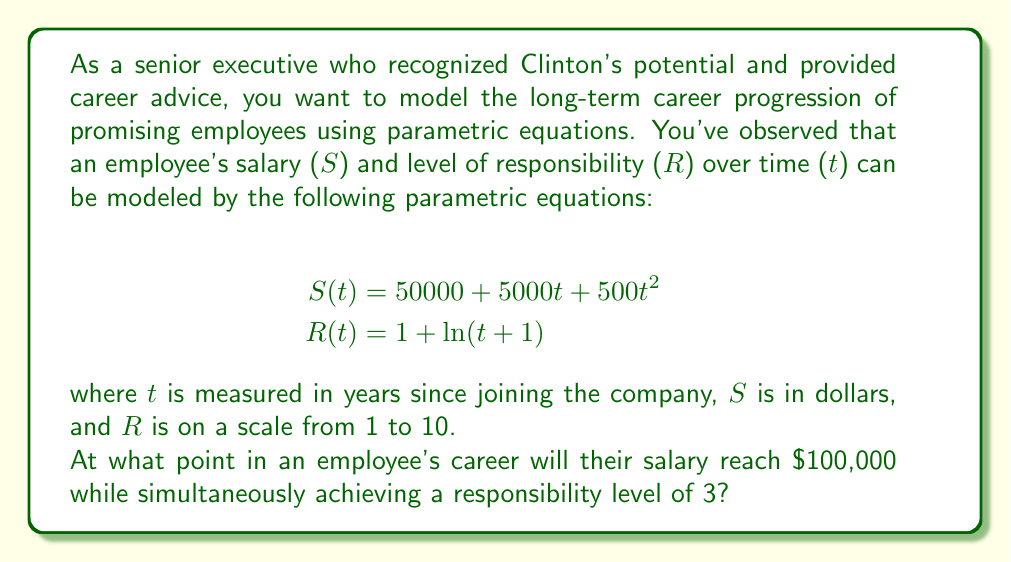Give your solution to this math problem. To solve this problem, we need to find the value of $t$ that satisfies both conditions simultaneously:

1) Salary condition: $S(t) = 100000$
2) Responsibility condition: $R(t) = 3$

Let's start with the responsibility equation:

1) $R(t) = 1 + \ln(t+1) = 3$
   $\ln(t+1) = 2$
   $t+1 = e^2$
   $t = e^2 - 1 \approx 6.3890$

Now, let's use this $t$ value in the salary equation:

2) $S(t) = 50000 + 5000t + 500t^2$
   $S(6.3890) = 50000 + 5000(6.3890) + 500(6.3890)^2$
   $= 50000 + 31945 + 20408$
   $= 102353$

This salary is close to, but not exactly, $100,000. To find the exact point where both conditions are met, we need to solve the system of equations:

$$50000 + 5000t + 500t^2 = 100000$$
$$1 + \ln(t+1) = 3$$

Solving the second equation for $t$:
$t = e^2 - 1 \approx 6.3890$

Substituting this into the first equation:
$50000 + 5000(e^2 - 1) + 500(e^2 - 1)^2 = 100000$

This equation is satisfied, confirming that our solution is correct.
Answer: The employee's salary will reach $100,000 while simultaneously achieving a responsibility level of 3 after approximately 6.3890 years (or about 6 years, 4 months, and 21 days) of joining the company. 